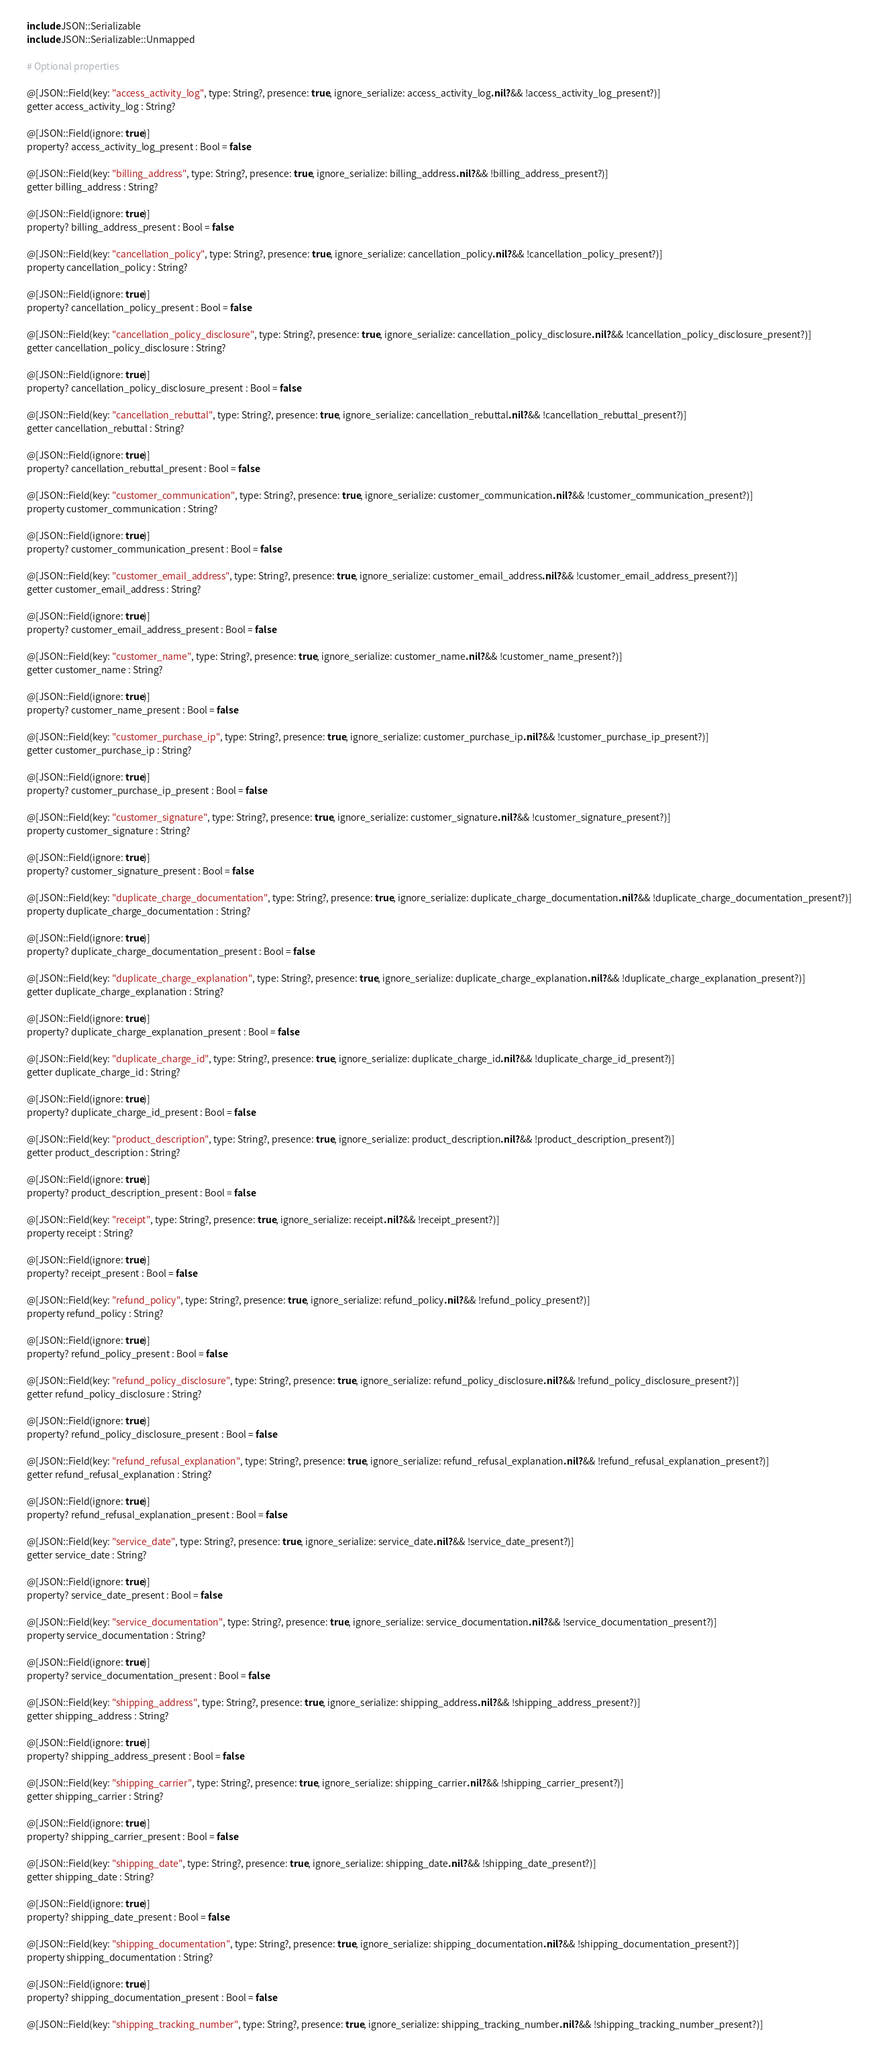<code> <loc_0><loc_0><loc_500><loc_500><_Crystal_>    include JSON::Serializable
    include JSON::Serializable::Unmapped

    # Optional properties

    @[JSON::Field(key: "access_activity_log", type: String?, presence: true, ignore_serialize: access_activity_log.nil? && !access_activity_log_present?)]
    getter access_activity_log : String?

    @[JSON::Field(ignore: true)]
    property? access_activity_log_present : Bool = false

    @[JSON::Field(key: "billing_address", type: String?, presence: true, ignore_serialize: billing_address.nil? && !billing_address_present?)]
    getter billing_address : String?

    @[JSON::Field(ignore: true)]
    property? billing_address_present : Bool = false

    @[JSON::Field(key: "cancellation_policy", type: String?, presence: true, ignore_serialize: cancellation_policy.nil? && !cancellation_policy_present?)]
    property cancellation_policy : String?

    @[JSON::Field(ignore: true)]
    property? cancellation_policy_present : Bool = false

    @[JSON::Field(key: "cancellation_policy_disclosure", type: String?, presence: true, ignore_serialize: cancellation_policy_disclosure.nil? && !cancellation_policy_disclosure_present?)]
    getter cancellation_policy_disclosure : String?

    @[JSON::Field(ignore: true)]
    property? cancellation_policy_disclosure_present : Bool = false

    @[JSON::Field(key: "cancellation_rebuttal", type: String?, presence: true, ignore_serialize: cancellation_rebuttal.nil? && !cancellation_rebuttal_present?)]
    getter cancellation_rebuttal : String?

    @[JSON::Field(ignore: true)]
    property? cancellation_rebuttal_present : Bool = false

    @[JSON::Field(key: "customer_communication", type: String?, presence: true, ignore_serialize: customer_communication.nil? && !customer_communication_present?)]
    property customer_communication : String?

    @[JSON::Field(ignore: true)]
    property? customer_communication_present : Bool = false

    @[JSON::Field(key: "customer_email_address", type: String?, presence: true, ignore_serialize: customer_email_address.nil? && !customer_email_address_present?)]
    getter customer_email_address : String?

    @[JSON::Field(ignore: true)]
    property? customer_email_address_present : Bool = false

    @[JSON::Field(key: "customer_name", type: String?, presence: true, ignore_serialize: customer_name.nil? && !customer_name_present?)]
    getter customer_name : String?

    @[JSON::Field(ignore: true)]
    property? customer_name_present : Bool = false

    @[JSON::Field(key: "customer_purchase_ip", type: String?, presence: true, ignore_serialize: customer_purchase_ip.nil? && !customer_purchase_ip_present?)]
    getter customer_purchase_ip : String?

    @[JSON::Field(ignore: true)]
    property? customer_purchase_ip_present : Bool = false

    @[JSON::Field(key: "customer_signature", type: String?, presence: true, ignore_serialize: customer_signature.nil? && !customer_signature_present?)]
    property customer_signature : String?

    @[JSON::Field(ignore: true)]
    property? customer_signature_present : Bool = false

    @[JSON::Field(key: "duplicate_charge_documentation", type: String?, presence: true, ignore_serialize: duplicate_charge_documentation.nil? && !duplicate_charge_documentation_present?)]
    property duplicate_charge_documentation : String?

    @[JSON::Field(ignore: true)]
    property? duplicate_charge_documentation_present : Bool = false

    @[JSON::Field(key: "duplicate_charge_explanation", type: String?, presence: true, ignore_serialize: duplicate_charge_explanation.nil? && !duplicate_charge_explanation_present?)]
    getter duplicate_charge_explanation : String?

    @[JSON::Field(ignore: true)]
    property? duplicate_charge_explanation_present : Bool = false

    @[JSON::Field(key: "duplicate_charge_id", type: String?, presence: true, ignore_serialize: duplicate_charge_id.nil? && !duplicate_charge_id_present?)]
    getter duplicate_charge_id : String?

    @[JSON::Field(ignore: true)]
    property? duplicate_charge_id_present : Bool = false

    @[JSON::Field(key: "product_description", type: String?, presence: true, ignore_serialize: product_description.nil? && !product_description_present?)]
    getter product_description : String?

    @[JSON::Field(ignore: true)]
    property? product_description_present : Bool = false

    @[JSON::Field(key: "receipt", type: String?, presence: true, ignore_serialize: receipt.nil? && !receipt_present?)]
    property receipt : String?

    @[JSON::Field(ignore: true)]
    property? receipt_present : Bool = false

    @[JSON::Field(key: "refund_policy", type: String?, presence: true, ignore_serialize: refund_policy.nil? && !refund_policy_present?)]
    property refund_policy : String?

    @[JSON::Field(ignore: true)]
    property? refund_policy_present : Bool = false

    @[JSON::Field(key: "refund_policy_disclosure", type: String?, presence: true, ignore_serialize: refund_policy_disclosure.nil? && !refund_policy_disclosure_present?)]
    getter refund_policy_disclosure : String?

    @[JSON::Field(ignore: true)]
    property? refund_policy_disclosure_present : Bool = false

    @[JSON::Field(key: "refund_refusal_explanation", type: String?, presence: true, ignore_serialize: refund_refusal_explanation.nil? && !refund_refusal_explanation_present?)]
    getter refund_refusal_explanation : String?

    @[JSON::Field(ignore: true)]
    property? refund_refusal_explanation_present : Bool = false

    @[JSON::Field(key: "service_date", type: String?, presence: true, ignore_serialize: service_date.nil? && !service_date_present?)]
    getter service_date : String?

    @[JSON::Field(ignore: true)]
    property? service_date_present : Bool = false

    @[JSON::Field(key: "service_documentation", type: String?, presence: true, ignore_serialize: service_documentation.nil? && !service_documentation_present?)]
    property service_documentation : String?

    @[JSON::Field(ignore: true)]
    property? service_documentation_present : Bool = false

    @[JSON::Field(key: "shipping_address", type: String?, presence: true, ignore_serialize: shipping_address.nil? && !shipping_address_present?)]
    getter shipping_address : String?

    @[JSON::Field(ignore: true)]
    property? shipping_address_present : Bool = false

    @[JSON::Field(key: "shipping_carrier", type: String?, presence: true, ignore_serialize: shipping_carrier.nil? && !shipping_carrier_present?)]
    getter shipping_carrier : String?

    @[JSON::Field(ignore: true)]
    property? shipping_carrier_present : Bool = false

    @[JSON::Field(key: "shipping_date", type: String?, presence: true, ignore_serialize: shipping_date.nil? && !shipping_date_present?)]
    getter shipping_date : String?

    @[JSON::Field(ignore: true)]
    property? shipping_date_present : Bool = false

    @[JSON::Field(key: "shipping_documentation", type: String?, presence: true, ignore_serialize: shipping_documentation.nil? && !shipping_documentation_present?)]
    property shipping_documentation : String?

    @[JSON::Field(ignore: true)]
    property? shipping_documentation_present : Bool = false

    @[JSON::Field(key: "shipping_tracking_number", type: String?, presence: true, ignore_serialize: shipping_tracking_number.nil? && !shipping_tracking_number_present?)]</code> 